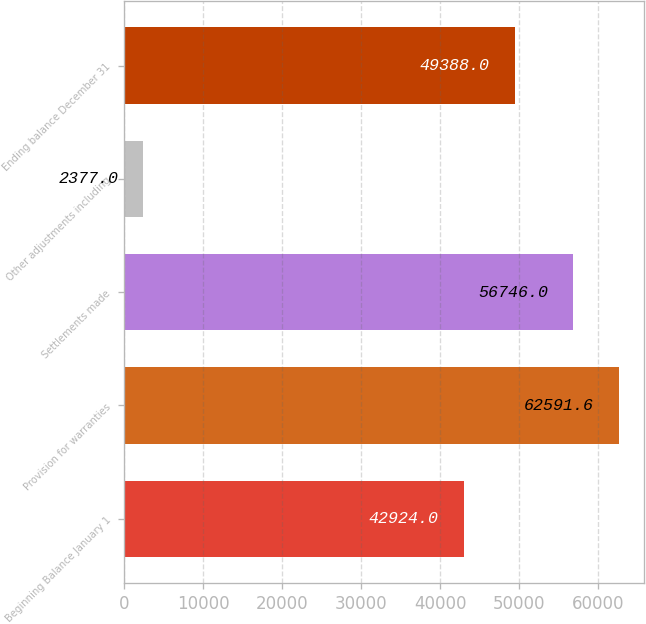<chart> <loc_0><loc_0><loc_500><loc_500><bar_chart><fcel>Beginning Balance January 1<fcel>Provision for warranties<fcel>Settlements made<fcel>Other adjustments including<fcel>Ending balance December 31<nl><fcel>42924<fcel>62591.6<fcel>56746<fcel>2377<fcel>49388<nl></chart> 